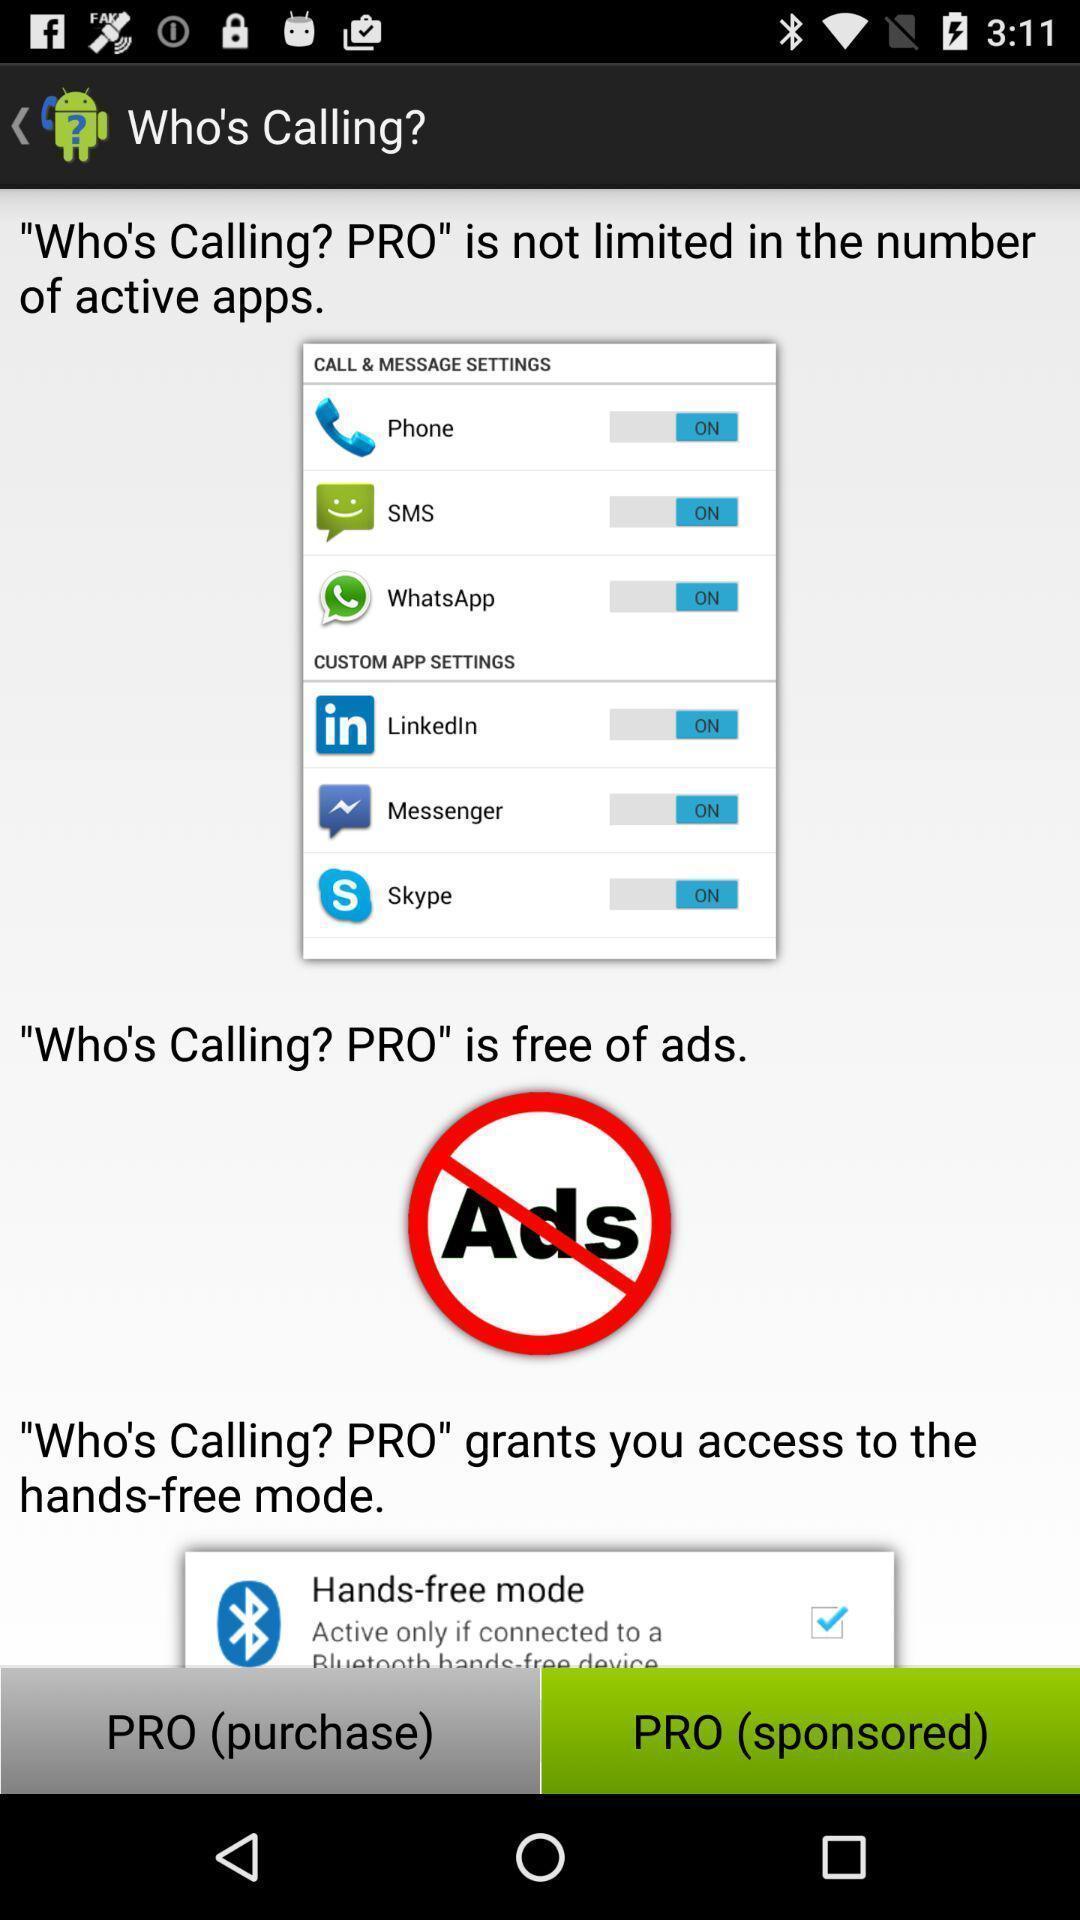Provide a textual representation of this image. Page displaying the advertisement of the app. 